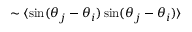<formula> <loc_0><loc_0><loc_500><loc_500>\sim \langle \sin ( \theta _ { j } - \theta _ { i } ) \, \sin ( \theta _ { j } - \theta _ { i } ) \rangle</formula> 